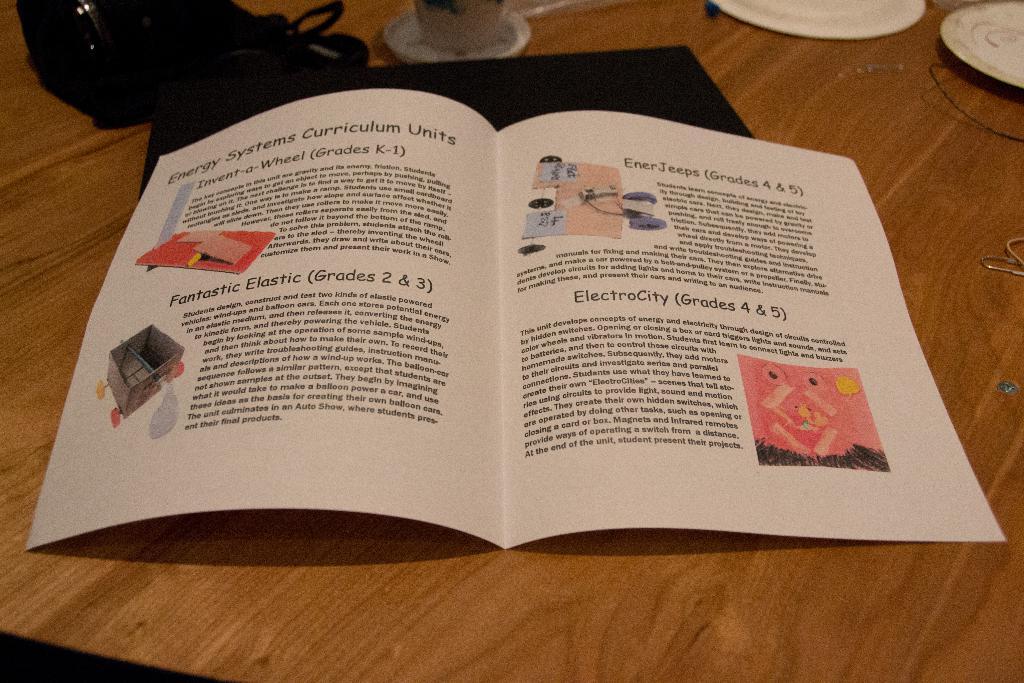What grades are the electrocity for?
Your answer should be compact. 4 & 5. What grades are fantastic elastic for?
Provide a succinct answer. 2 & 3. 